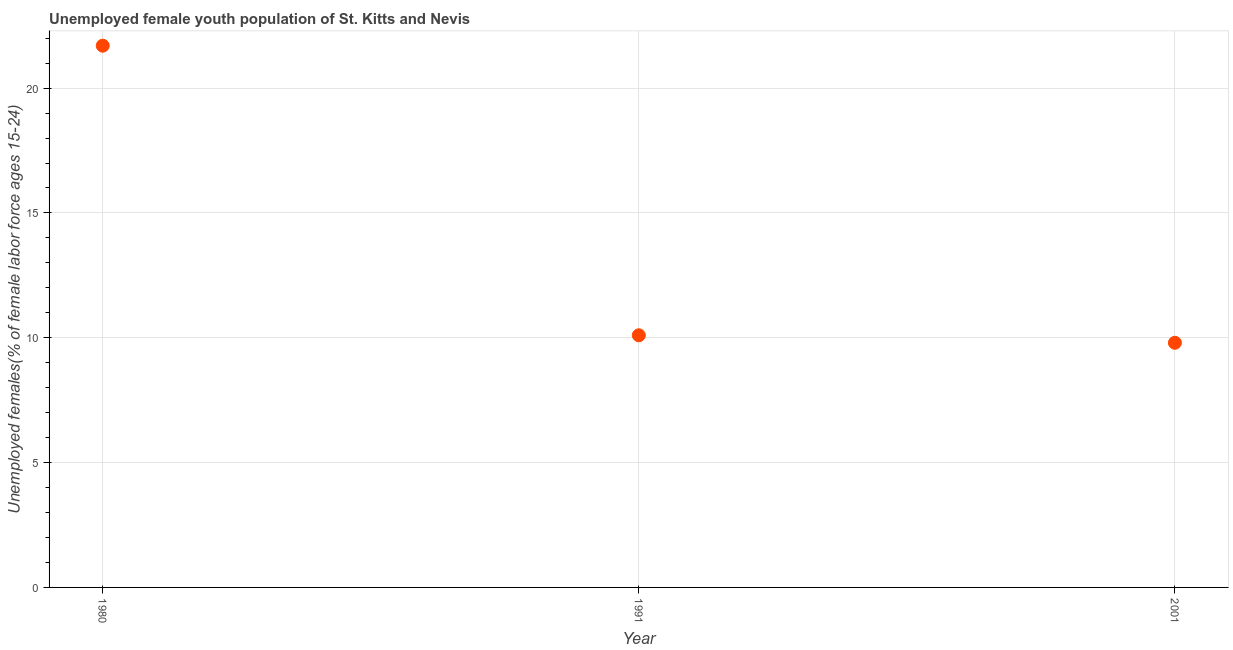What is the unemployed female youth in 2001?
Your response must be concise. 9.8. Across all years, what is the maximum unemployed female youth?
Your answer should be compact. 21.7. Across all years, what is the minimum unemployed female youth?
Give a very brief answer. 9.8. In which year was the unemployed female youth minimum?
Your answer should be compact. 2001. What is the sum of the unemployed female youth?
Offer a terse response. 41.6. What is the difference between the unemployed female youth in 1980 and 2001?
Provide a succinct answer. 11.9. What is the average unemployed female youth per year?
Keep it short and to the point. 13.87. What is the median unemployed female youth?
Offer a terse response. 10.1. In how many years, is the unemployed female youth greater than 11 %?
Provide a short and direct response. 1. What is the ratio of the unemployed female youth in 1991 to that in 2001?
Offer a terse response. 1.03. Is the unemployed female youth in 1980 less than that in 2001?
Provide a short and direct response. No. Is the difference between the unemployed female youth in 1980 and 2001 greater than the difference between any two years?
Make the answer very short. Yes. What is the difference between the highest and the second highest unemployed female youth?
Offer a very short reply. 11.6. What is the difference between the highest and the lowest unemployed female youth?
Make the answer very short. 11.9. What is the difference between two consecutive major ticks on the Y-axis?
Offer a terse response. 5. Does the graph contain any zero values?
Your response must be concise. No. What is the title of the graph?
Ensure brevity in your answer.  Unemployed female youth population of St. Kitts and Nevis. What is the label or title of the Y-axis?
Ensure brevity in your answer.  Unemployed females(% of female labor force ages 15-24). What is the Unemployed females(% of female labor force ages 15-24) in 1980?
Offer a terse response. 21.7. What is the Unemployed females(% of female labor force ages 15-24) in 1991?
Provide a succinct answer. 10.1. What is the Unemployed females(% of female labor force ages 15-24) in 2001?
Your response must be concise. 9.8. What is the ratio of the Unemployed females(% of female labor force ages 15-24) in 1980 to that in 1991?
Give a very brief answer. 2.15. What is the ratio of the Unemployed females(% of female labor force ages 15-24) in 1980 to that in 2001?
Your answer should be compact. 2.21. What is the ratio of the Unemployed females(% of female labor force ages 15-24) in 1991 to that in 2001?
Provide a succinct answer. 1.03. 